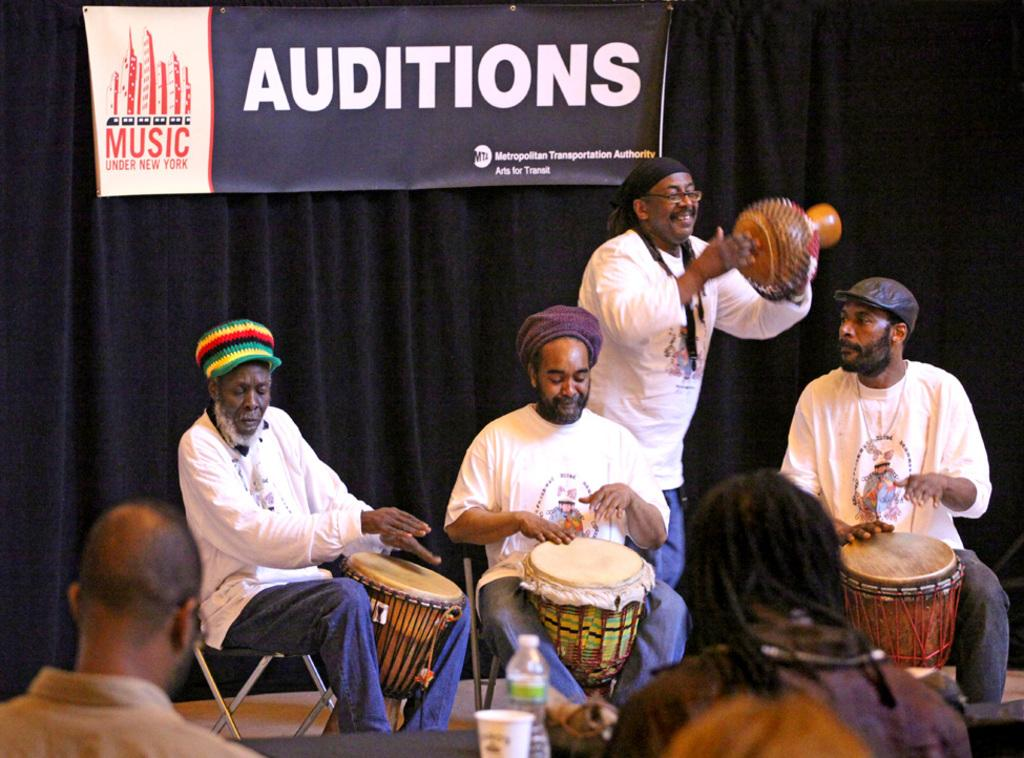What are the people in the image doing? The people in the image are playing musical instruments. What objects can be seen on the table in the image? There is a bottle and a cup on the table in the image. What can be seen in the background of the image? There is a curtain and a banner in the background. What type of insect is crawling on the banner in the image? There is no insect present on the banner in the image. 